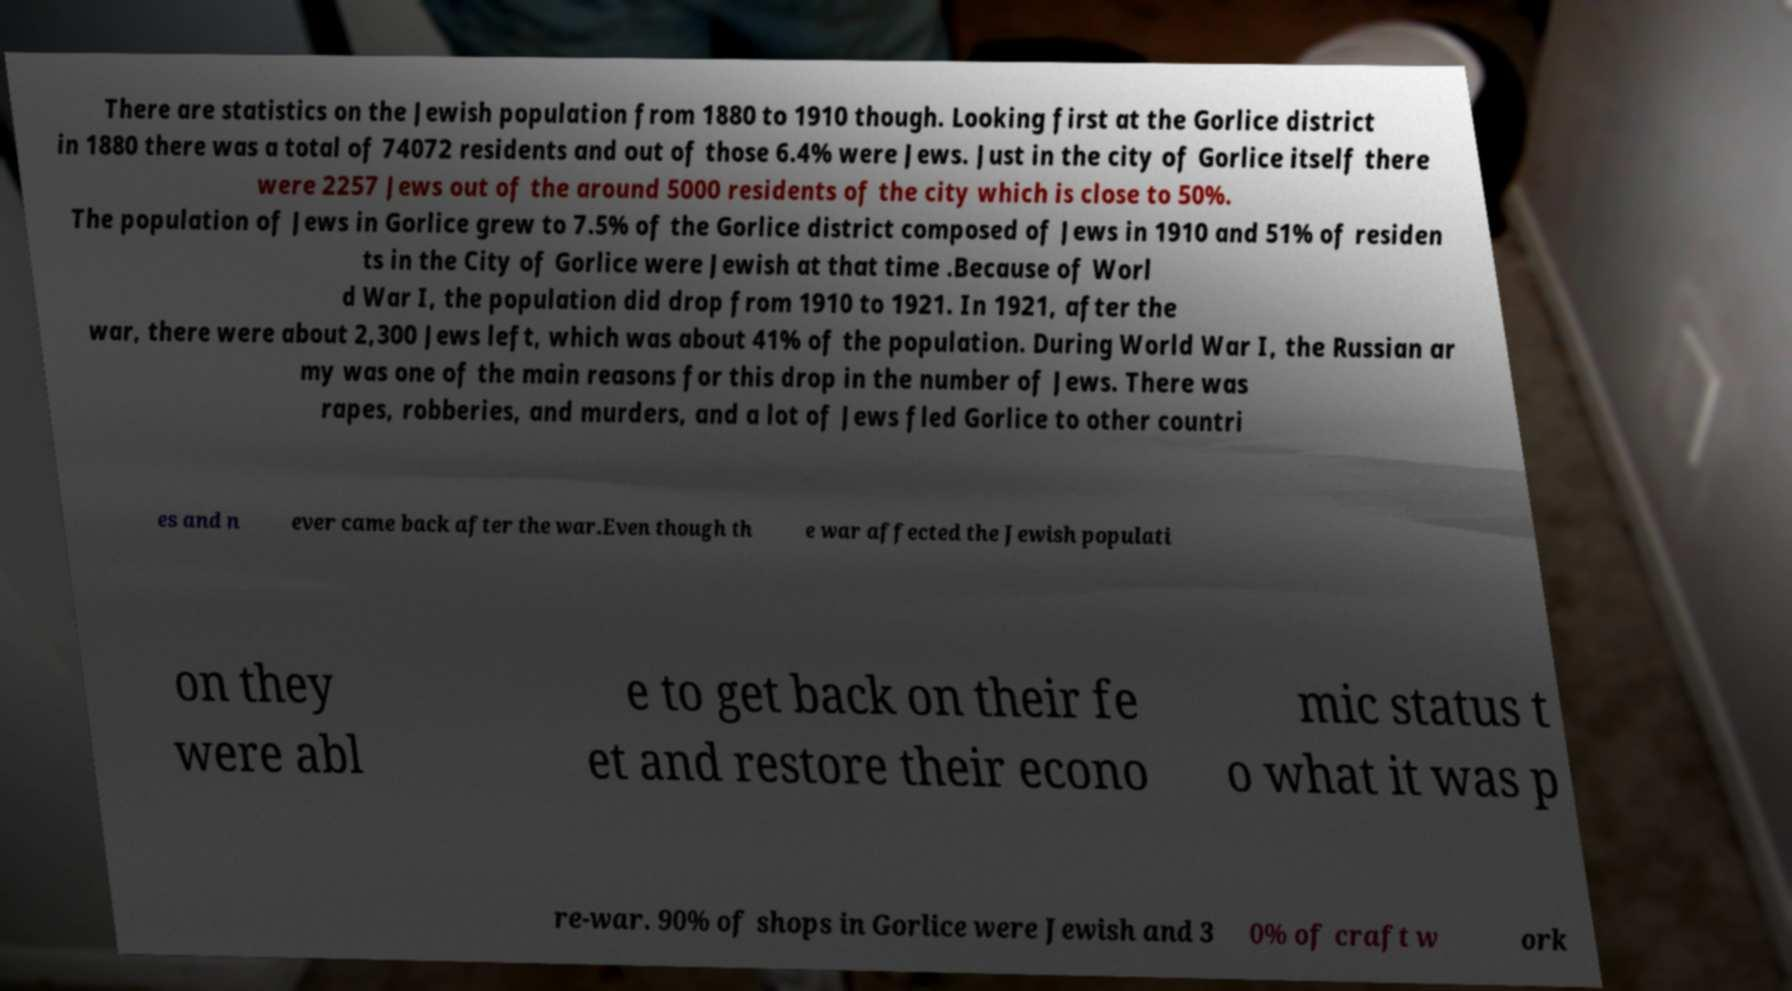Could you extract and type out the text from this image? There are statistics on the Jewish population from 1880 to 1910 though. Looking first at the Gorlice district in 1880 there was a total of 74072 residents and out of those 6.4% were Jews. Just in the city of Gorlice itself there were 2257 Jews out of the around 5000 residents of the city which is close to 50%. The population of Jews in Gorlice grew to 7.5% of the Gorlice district composed of Jews in 1910 and 51% of residen ts in the City of Gorlice were Jewish at that time .Because of Worl d War I, the population did drop from 1910 to 1921. In 1921, after the war, there were about 2,300 Jews left, which was about 41% of the population. During World War I, the Russian ar my was one of the main reasons for this drop in the number of Jews. There was rapes, robberies, and murders, and a lot of Jews fled Gorlice to other countri es and n ever came back after the war.Even though th e war affected the Jewish populati on they were abl e to get back on their fe et and restore their econo mic status t o what it was p re-war. 90% of shops in Gorlice were Jewish and 3 0% of craft w ork 